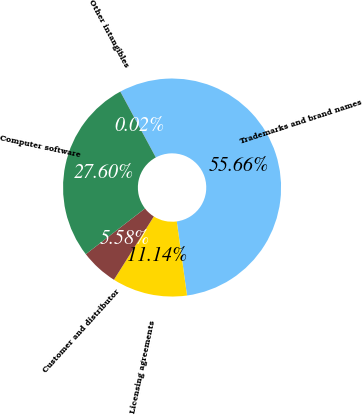Convert chart. <chart><loc_0><loc_0><loc_500><loc_500><pie_chart><fcel>Trademarks and brand names<fcel>Licensing agreements<fcel>Customer and distributor<fcel>Computer software<fcel>Other intangibles<nl><fcel>55.66%<fcel>11.14%<fcel>5.58%<fcel>27.6%<fcel>0.02%<nl></chart> 